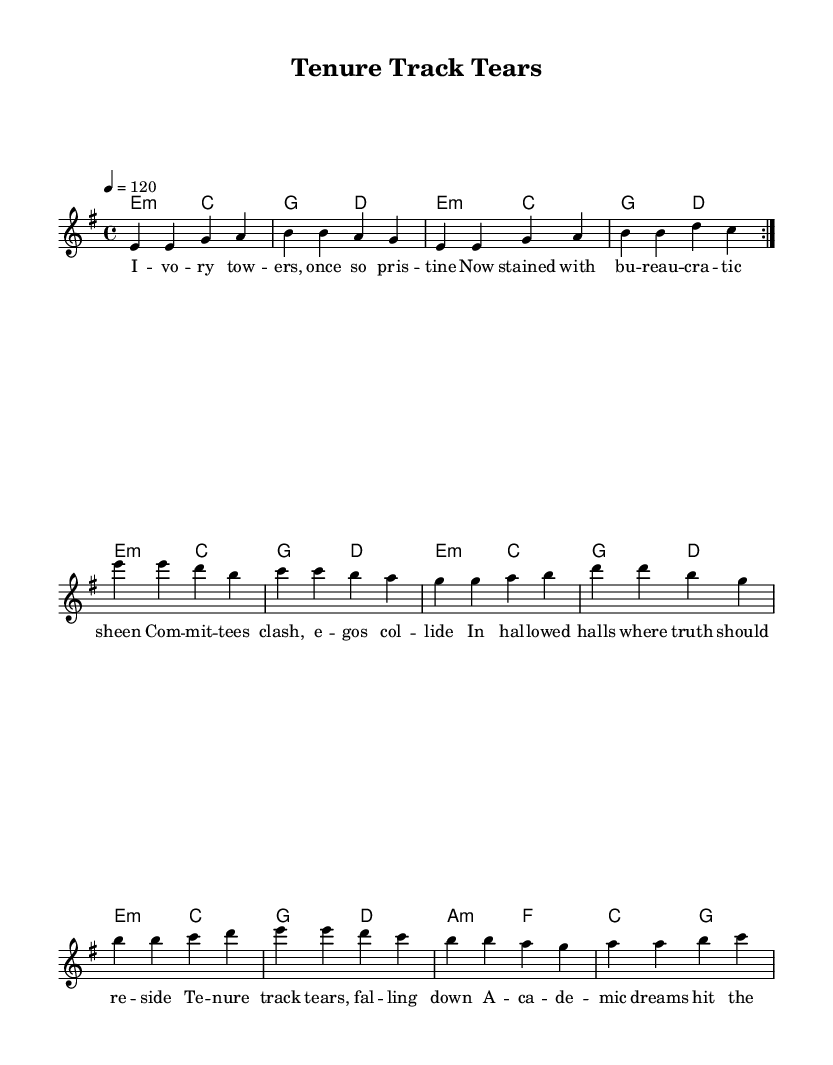What is the key signature of this music? The key signature is E minor, which has one sharp (F sharp). This can be determined by analyzing the beginning of the score where the key is stated, showing E minor is the tonal center.
Answer: E minor What is the time signature of this piece? The time signature is 4/4, indicating that there are four beats in each measure, and the quarter note gets one beat. This can be observed at the start of the score, where the time signature is explicitly indicated.
Answer: 4/4 What is the tempo marking for this composition? The tempo marking is 120 beats per minute, as shown at the beginning of the score. This tempo is indicated by the number 4=120, meaning there are four beats in a measure, and one beat corresponds to a tempo of 120 beats per minute.
Answer: 120 What is the primary theme explored in the lyrics? The primary theme is the emotional toll of academic politics and power struggles, as seen from the lyrics discussing bureaucracy, committee clashes, and the resulting distress within academic settings. The lyrics directly reference these themes.
Answer: Academic politics How many measures are in the melody section before the chorus? There are 16 measures in the melody section before the chorus can be identified, as the melody repeats two sequences of 8 measures plus transitions into the chorus lyrics. This can be counted by noticing the repeat and the structure of the melody provided.
Answer: 16 What does the term "tenure track tears" metaphorically refer to? The term "tenure track tears" metaphorically refers to the emotional distress faculty experience due to the pressures of achieving tenure, symbolizing the struggles and sacrifices faced in academia. This ties to the overall dark tone of punk music that critiques social institutions.
Answer: Emotional distress 